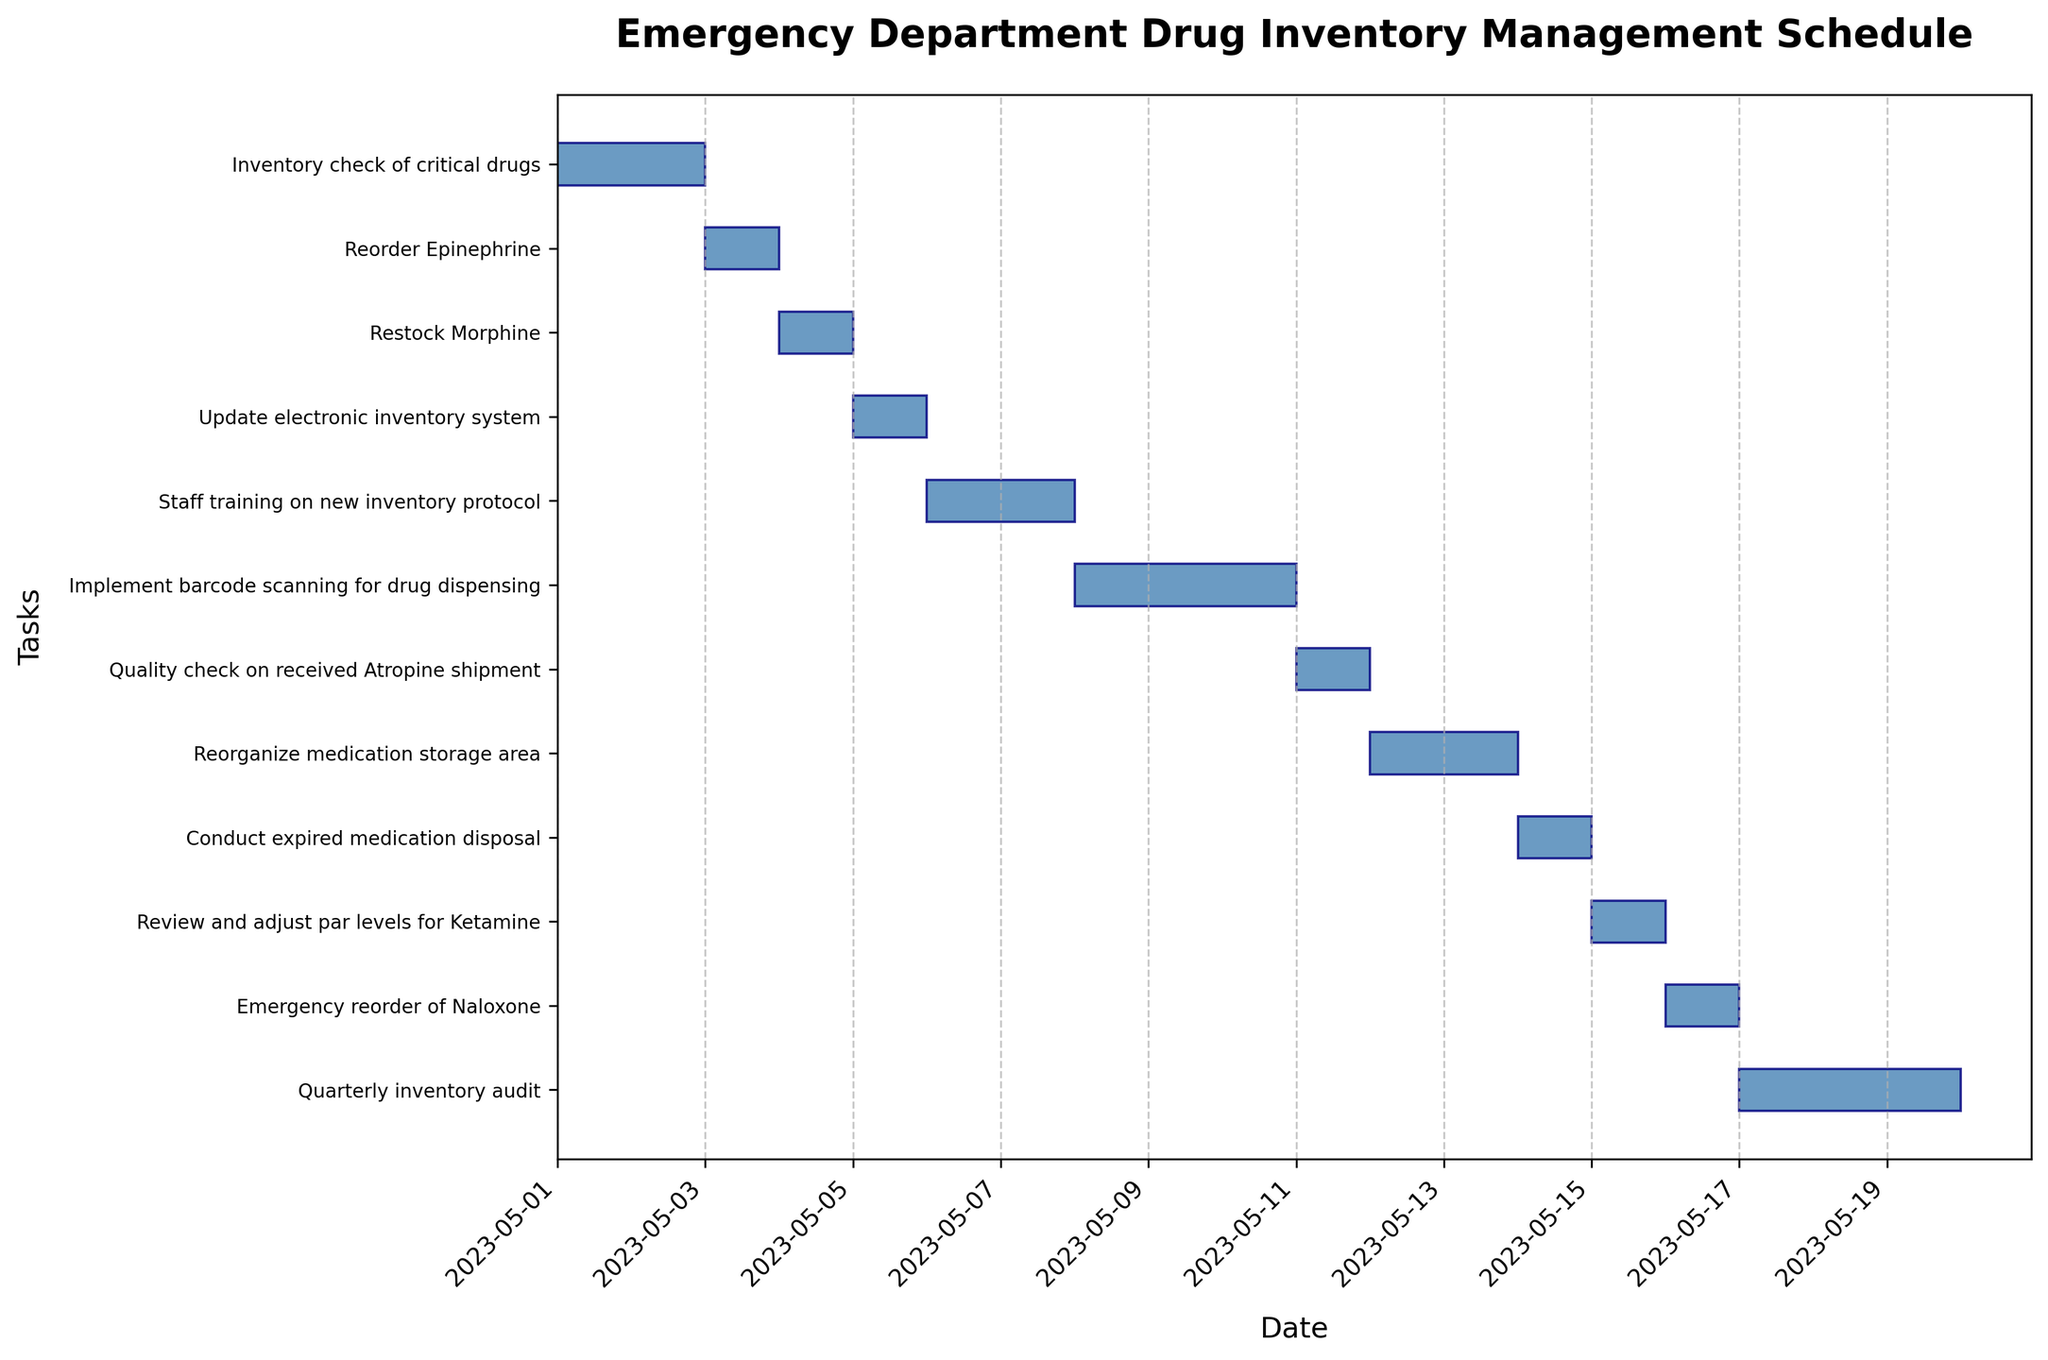What is the title of the figure? The title of the figure is usually located at the top and provides a brief description of what the graph is about. In this case, you can find the title at the top, centered.
Answer: Emergency Department Drug Inventory Management Schedule Which task has the shortest duration? To find the task with the shortest duration, look at the horizontal bars in the Gantt chart and identify the one that spans the fewest days. There are multiple tasks of 1-day duration like "Reorder Epinephrine," "Restock Morphine," and others.
Answer: Multiple tasks including "Reorder Epinephrine" and "Restock Morphine" How many tasks are scheduled to start in May 2023? Examine the start dates listed along the left y-axis and count how many tasks begin within the range of May 2023. Every task in this Gantt chart starts in May 2023, as it is specified for the month of May 2023.
Answer: 11 tasks What task starts immediately after “Inventory check of critical drugs”? Look at the horizontal bar for “Inventory check of critical drugs,” which ends on 2023-05-03. The next task that starts on or around this date is “Reorder Epinephrine.”
Answer: Reorder Epinephrine Which task has the longest duration, and how many days does it span? Identify the task with the longest horizontal bar in the Gantt chart. “Implement barcode scanning for drug dispensing” has the longest bar and spans 3 days from May 8 to May 11.
Answer: Implement barcode scanning for drug dispensing, 3 days How many tasks finish by May 10, 2023? To determine the tasks finishing by May 10, check the end dates of all tasks and count those that fall on or before May 10, 2023. The tasks that finish by this date are “Inventory check of critical drugs,” “Reorder Epinephrine,” “Restock Morphine,” and “Update electronic inventory system.”
Answer: 4 tasks Which tasks overlap with the “Quarterly inventory audit”? The "Quarterly inventory audit" runs from May 17 to May 20. Check which other tasks have bars that overlap this time period. No tasks overlap with the “Quarterly inventory audit” as it stands alone at the end.
Answer: None Compare the duration of "Staff training on new inventory protocol" and "Conduct expired medication disposal." Which one is longer and by how many days? "Staff training on new inventory protocol" lasts 2 days (May 6 - May 8), while "Conduct expired medication disposal" lasts 1 day (May 14). The difference in their durations is 1 day.
Answer: Staff training on new inventory protocol, 1 day longer Does the "Quality check on received Atropine shipment" happen before or after "Restock Morphine"? "Restock Morphine" ends on May 5, and the “Quality check on received Atropine shipment” happens on May 11-12. Therefore, it happens after.
Answer: After 